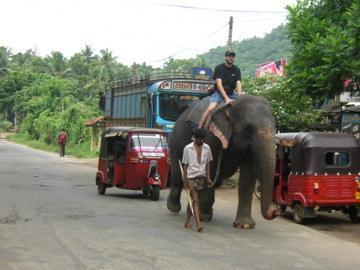The white man is most likely what?
Make your selection and explain in format: 'Answer: answer
Rationale: rationale.'
Options: Warrior, tourist, prisoner, native. Answer: tourist.
Rationale: Usually locals don't ride elephants; this seems like an activity for people visiting. 